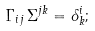Convert formula to latex. <formula><loc_0><loc_0><loc_500><loc_500>\Gamma _ { i j } \, \Sigma ^ { j k } = \delta ^ { i } _ { k } ;</formula> 